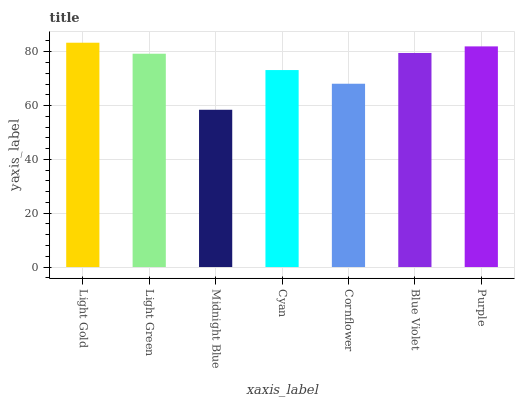Is Midnight Blue the minimum?
Answer yes or no. Yes. Is Light Gold the maximum?
Answer yes or no. Yes. Is Light Green the minimum?
Answer yes or no. No. Is Light Green the maximum?
Answer yes or no. No. Is Light Gold greater than Light Green?
Answer yes or no. Yes. Is Light Green less than Light Gold?
Answer yes or no. Yes. Is Light Green greater than Light Gold?
Answer yes or no. No. Is Light Gold less than Light Green?
Answer yes or no. No. Is Light Green the high median?
Answer yes or no. Yes. Is Light Green the low median?
Answer yes or no. Yes. Is Cyan the high median?
Answer yes or no. No. Is Light Gold the low median?
Answer yes or no. No. 